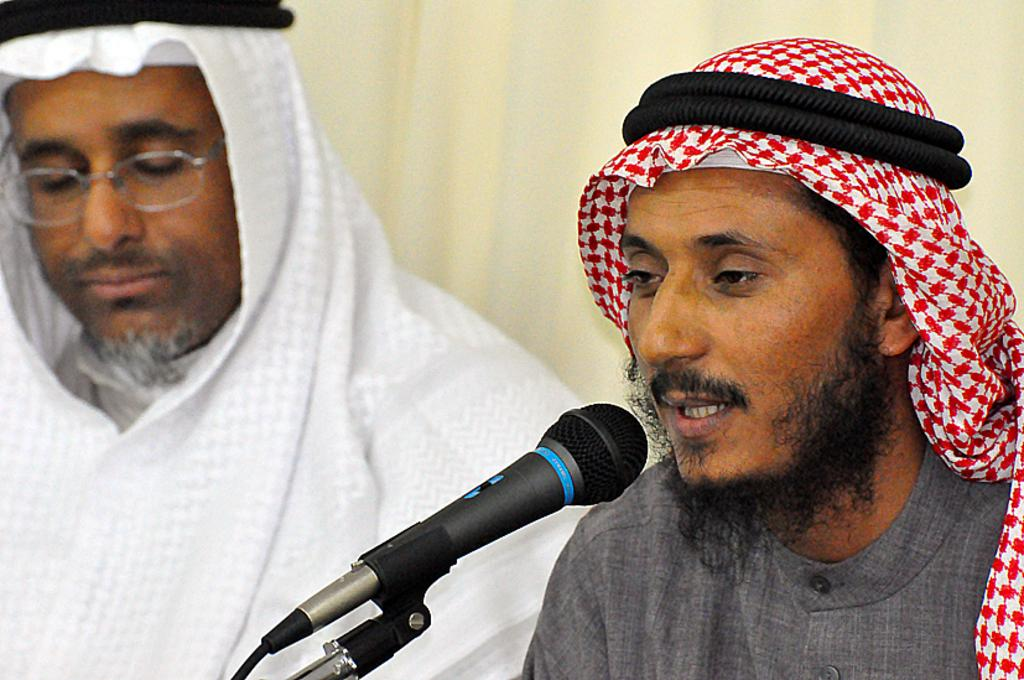How many people are in the image? There are two people in the image. What are the people wearing? The people are wearing different color dresses. What is one person doing in the image? One person is holding a mic. What is the background color in the image? The background color in the image is cream. What type of surprise can be seen in the library in the image? There is no library or surprise present in the image; it features two people wearing different color dresses, one of whom is holding a mic. What is the thumb doing in the image? There is no thumb visible in the image. 